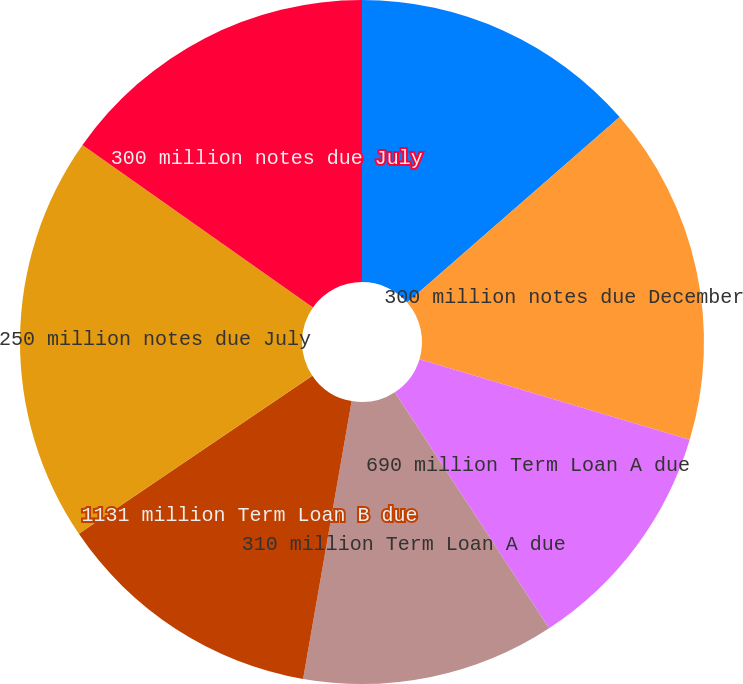Convert chart. <chart><loc_0><loc_0><loc_500><loc_500><pie_chart><fcel>450 million notes due December<fcel>300 million notes due December<fcel>690 million Term Loan A due<fcel>310 million Term Loan A due<fcel>1131 million Term Loan B due<fcel>250 million notes due July<fcel>300 million notes due July<nl><fcel>13.58%<fcel>16.04%<fcel>11.17%<fcel>11.97%<fcel>12.77%<fcel>19.25%<fcel>15.23%<nl></chart> 